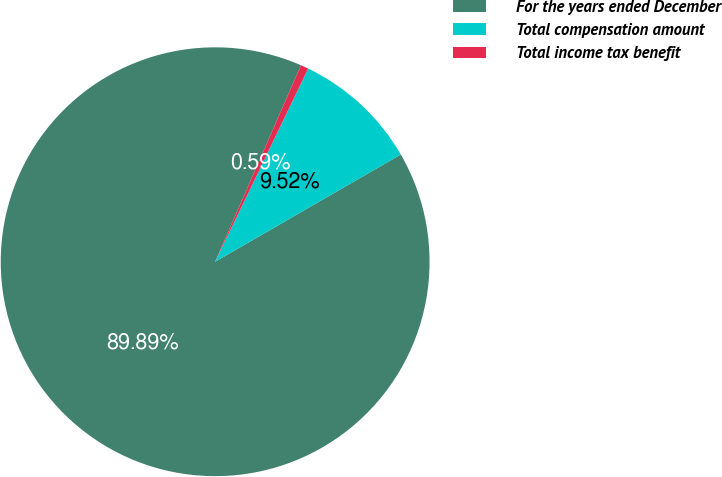Convert chart. <chart><loc_0><loc_0><loc_500><loc_500><pie_chart><fcel>For the years ended December<fcel>Total compensation amount<fcel>Total income tax benefit<nl><fcel>89.9%<fcel>9.52%<fcel>0.59%<nl></chart> 